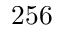Convert formula to latex. <formula><loc_0><loc_0><loc_500><loc_500>2 5 6</formula> 